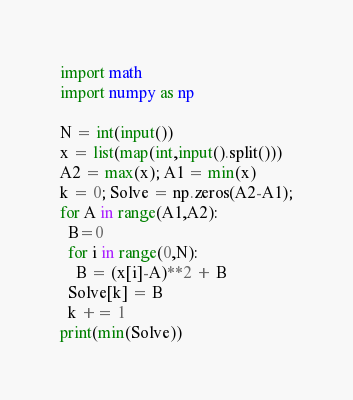Convert code to text. <code><loc_0><loc_0><loc_500><loc_500><_Python_>import math
import numpy as np

N = int(input())
x = list(map(int,input().split()))
A2 = max(x); A1 = min(x)
k = 0; Solve = np.zeros(A2-A1);
for A in range(A1,A2):
  B=0
  for i in range(0,N):
    B = (x[i]-A)**2 + B
  Solve[k] = B
  k += 1
print(min(Solve))</code> 